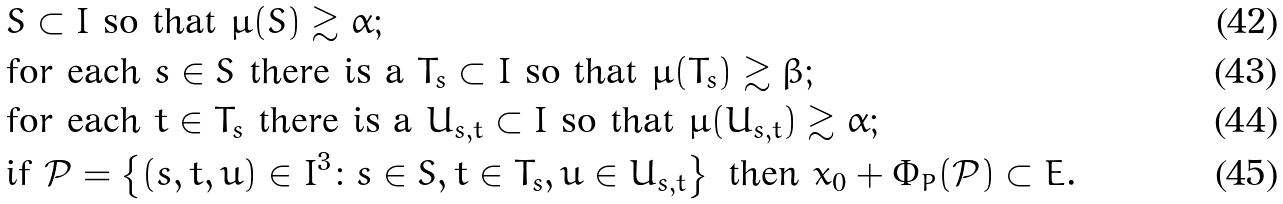<formula> <loc_0><loc_0><loc_500><loc_500>& S \subset I \text { so that  } \mu ( S ) \gtrsim \alpha ; \\ & \text {for each } s \in S \text { there is a } T _ { s } \subset I \text { so that } \mu ( T _ { s } ) \gtrsim \beta ; \\ & \text {for each } t \in T _ { s } \text { there is a } U _ { s , t } \subset I \text { so that } \mu ( U _ { s , t } ) \gtrsim \alpha ; \\ & \text {if } \mathcal { P } = \left \{ ( s , t , u ) \in I ^ { 3 } \colon s \in S , t \in T _ { s } , u \in U _ { s , t } \right \} \text { then } x _ { 0 } + \Phi _ { P } ( \mathcal { P } ) \subset E .</formula> 